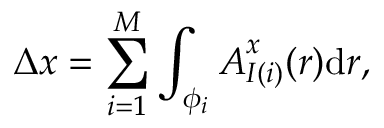Convert formula to latex. <formula><loc_0><loc_0><loc_500><loc_500>\Delta x = \sum _ { i = 1 } ^ { M } \int _ { \phi _ { i } } { A _ { I ( i ) } ^ { x } ( r ) d r } ,</formula> 